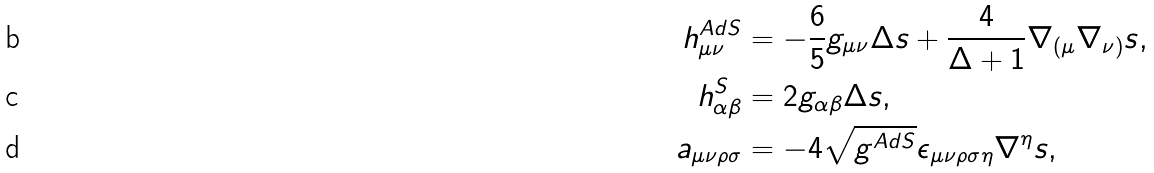<formula> <loc_0><loc_0><loc_500><loc_500>h _ { \mu \nu } ^ { A d S } & = - \frac { 6 } { 5 } g _ { \mu \nu } \Delta s + \frac { 4 } { \Delta + 1 } \nabla _ { ( \mu } \nabla _ { \nu ) } s , \\ h _ { \alpha \beta } ^ { S } & = 2 g _ { \alpha \beta } \Delta s , \\ a _ { \mu \nu \rho \sigma } & = - 4 \sqrt { g ^ { A d S } } \epsilon _ { \mu \nu \rho \sigma \eta } \nabla ^ { \eta } s ,</formula> 